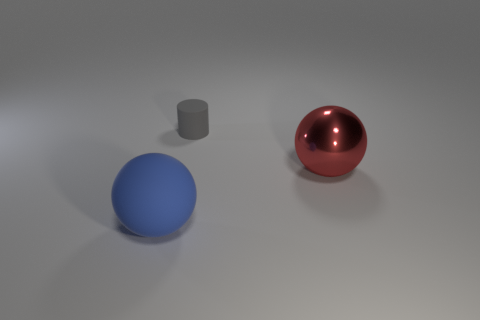How many large gray balls have the same material as the big blue ball?
Offer a terse response. 0. What number of gray objects are the same size as the red metal ball?
Offer a terse response. 0. What is the material of the large object that is right of the large ball that is left of the sphere that is right of the gray rubber cylinder?
Offer a terse response. Metal. What number of things are large red metal things or tiny objects?
Ensure brevity in your answer.  2. Is there any other thing that has the same material as the cylinder?
Provide a succinct answer. Yes. There is a gray thing; what shape is it?
Give a very brief answer. Cylinder. There is a matte thing right of the object that is on the left side of the small matte cylinder; what shape is it?
Offer a terse response. Cylinder. Is the large ball that is to the right of the small rubber thing made of the same material as the cylinder?
Provide a succinct answer. No. What number of gray things are either rubber objects or objects?
Your response must be concise. 1. Is there a rubber thing of the same color as the big matte sphere?
Offer a very short reply. No. 